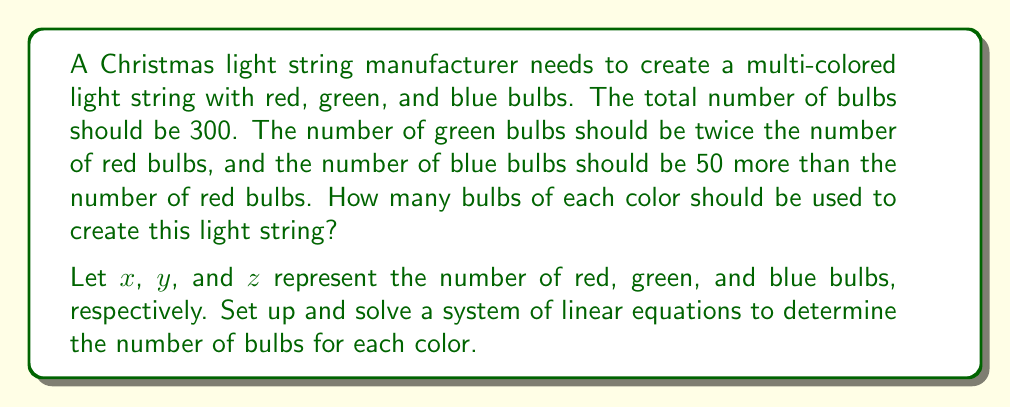Can you answer this question? Let's solve this problem step by step:

1. Define variables:
   $x$ = number of red bulbs
   $y$ = number of green bulbs
   $z$ = number of blue bulbs

2. Set up the system of linear equations based on the given information:
   $$\begin{cases}
   x + y + z = 300 & \text{(total number of bulbs)} \\
   y = 2x & \text{(green is twice red)} \\
   z = x + 50 & \text{(blue is 50 more than red)}
   \end{cases}$$

3. Substitute the expressions for $y$ and $z$ into the first equation:
   $$x + 2x + (x + 50) = 300$$

4. Simplify the equation:
   $$4x + 50 = 300$$

5. Solve for $x$:
   $$4x = 250$$
   $$x = 62.5$$

6. Since we can't have fractional bulbs, we round down to 62 red bulbs.

7. Calculate the number of green bulbs:
   $$y = 2x = 2(62) = 124$$

8. Calculate the number of blue bulbs:
   $$z = x + 50 = 62 + 50 = 112$$

9. Verify the total:
   $$62 + 124 + 112 = 298$$

   This is as close as we can get to 300 bulbs while maintaining the required ratios.
Answer: 62 red, 124 green, 112 blue 